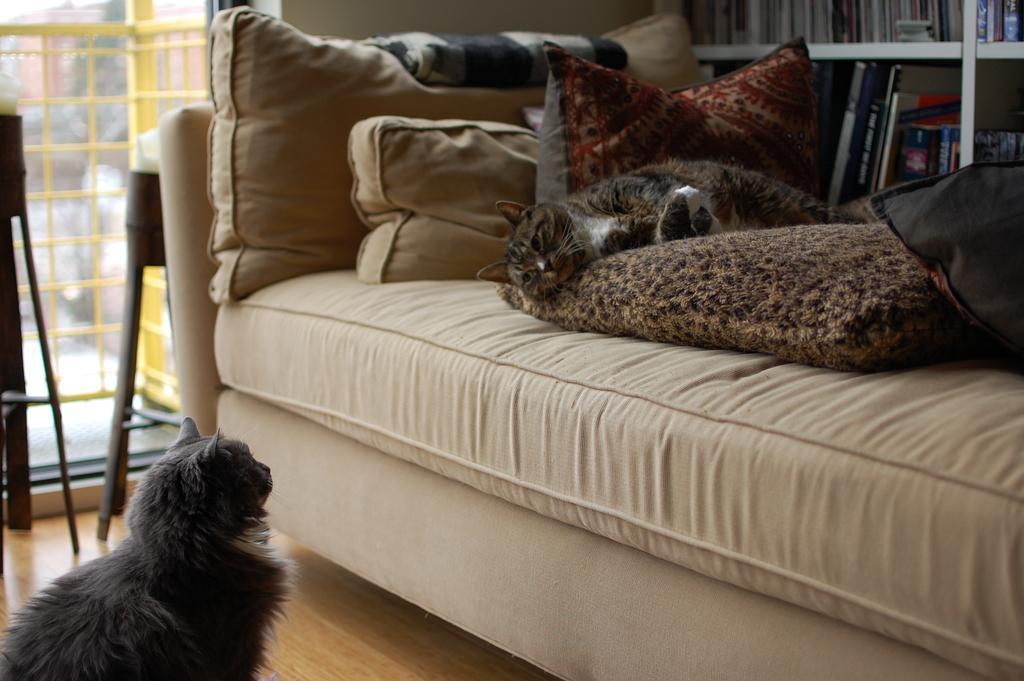In one or two sentences, can you explain what this image depicts? In this image i can see a cat on floor at the back ground i can see the other cat on couch, few pillows, few books in a rack and a wall. 